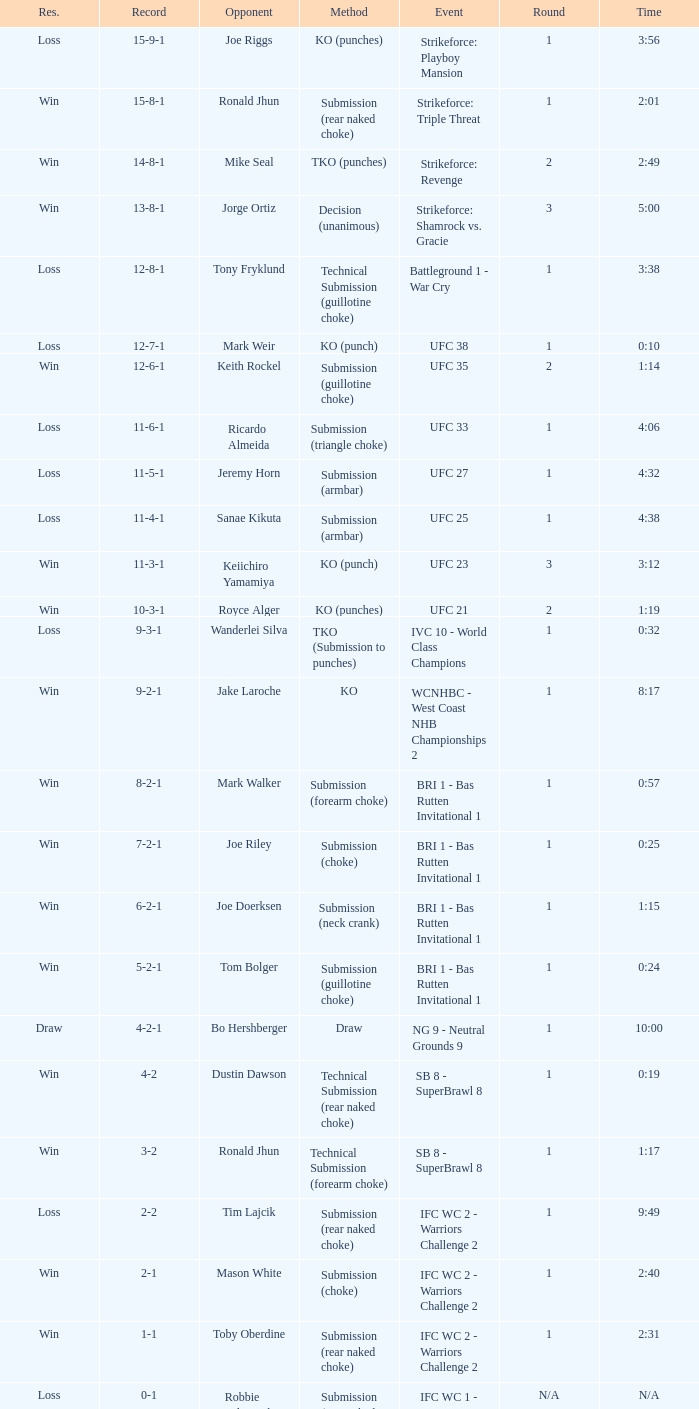What was the determination for the combat against tom bolger by submission (guillotine choke)? Win. 